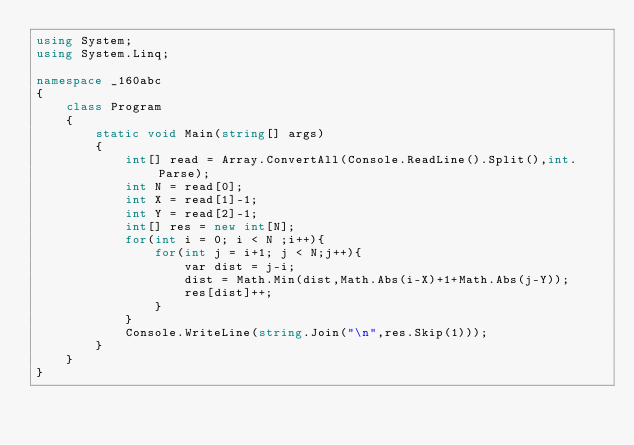Convert code to text. <code><loc_0><loc_0><loc_500><loc_500><_C#_>using System;
using System.Linq;

namespace _160abc
{
    class Program
    {
        static void Main(string[] args)
        {    
            int[] read = Array.ConvertAll(Console.ReadLine().Split(),int.Parse);
            int N = read[0];
            int X = read[1]-1;
            int Y = read[2]-1;
            int[] res = new int[N];
            for(int i = 0; i < N ;i++){
                for(int j = i+1; j < N;j++){
                    var dist = j-i;
                    dist = Math.Min(dist,Math.Abs(i-X)+1+Math.Abs(j-Y));
                    res[dist]++;
                }
            }
            Console.WriteLine(string.Join("\n",res.Skip(1)));
        }
    }
}
</code> 